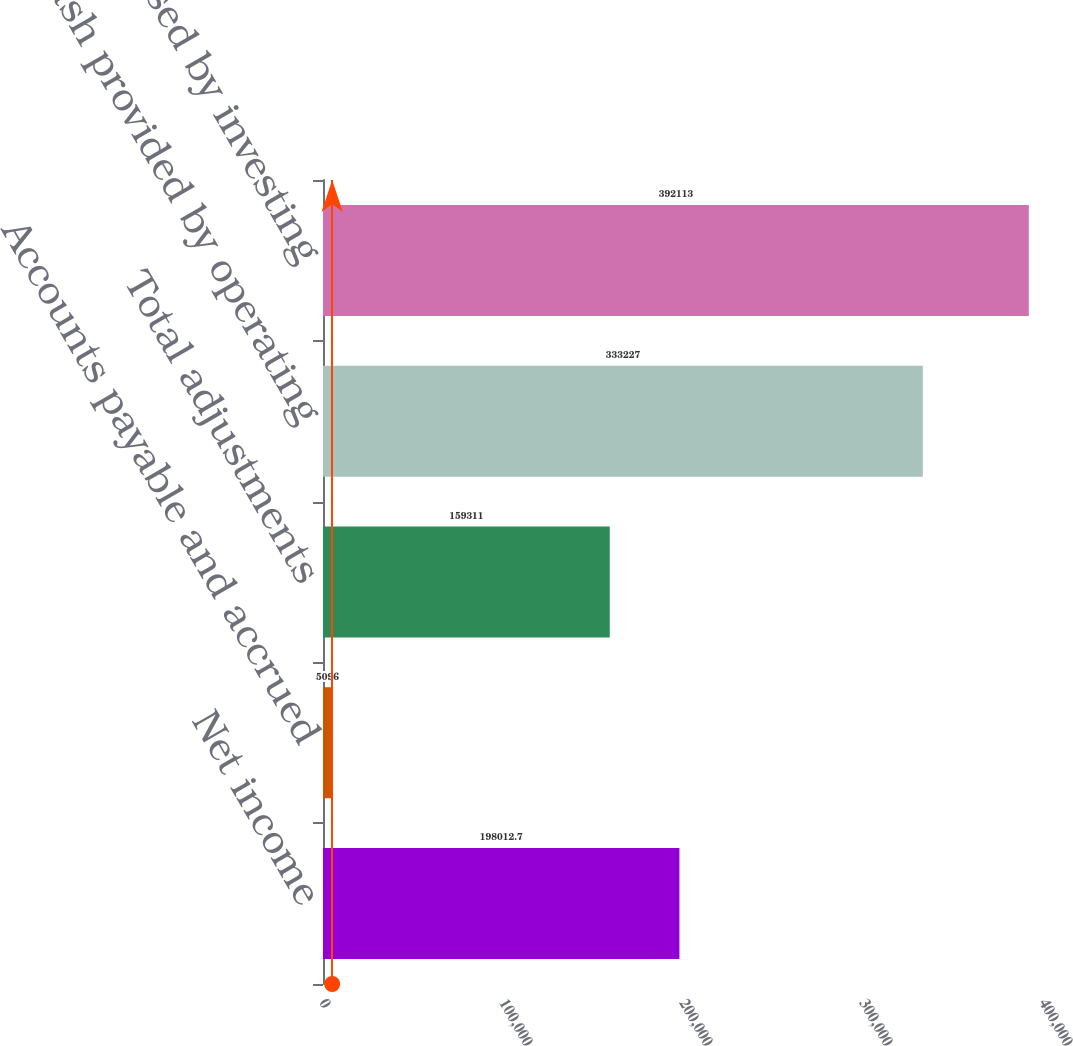<chart> <loc_0><loc_0><loc_500><loc_500><bar_chart><fcel>Net income<fcel>Accounts payable and accrued<fcel>Total adjustments<fcel>Net cash provided by operating<fcel>Net cash used by investing<nl><fcel>198013<fcel>5096<fcel>159311<fcel>333227<fcel>392113<nl></chart> 